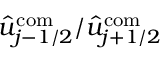<formula> <loc_0><loc_0><loc_500><loc_500>\hat { u } _ { j - 1 / 2 } ^ { c o m } / \hat { u } _ { j + 1 / 2 } ^ { c o m }</formula> 